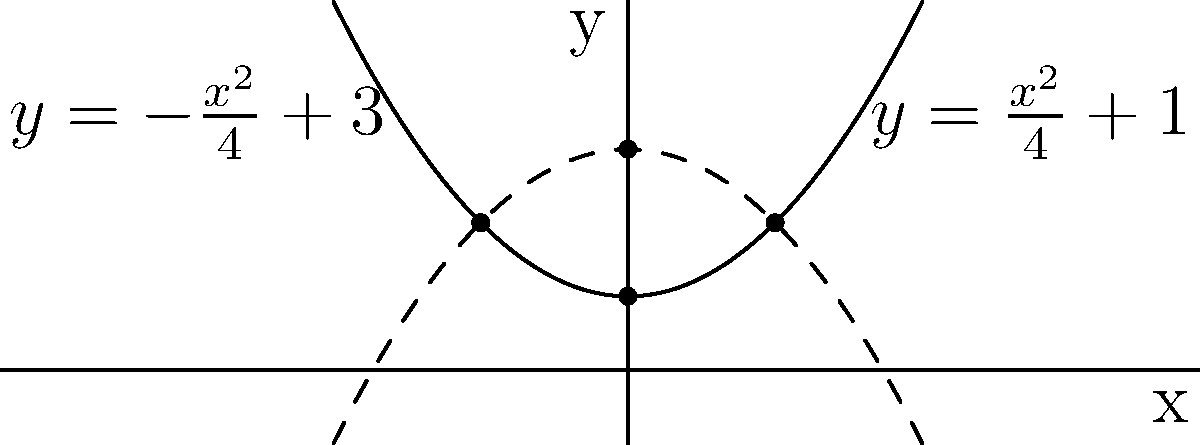In the context of analytic geometry, consider the two parabolas shown in the graph. The solid line represents $y=\frac{x^2}{4}+1$, and the dashed line represents $y=-\frac{x^2}{4}+3$. What is the area of the region enclosed by these two parabolas? To find the area enclosed by the two parabolas, we'll follow these steps:

1) First, we need to find the points of intersection. We can do this by equating the two equations:

   $\frac{x^2}{4}+1 = -\frac{x^2}{4}+3$

2) Simplifying:
   
   $\frac{x^2}{2} = 2$
   $x^2 = 4$
   $x = \pm 2$

3) So the parabolas intersect at $(-2,2)$ and $(2,2)$.

4) The area between the curves can be found by integrating the difference of the functions from $-2$ to $2$:

   $A = \int_{-2}^{2} [(-\frac{x^2}{4}+3) - (\frac{x^2}{4}+1)] dx$

5) Simplifying the integrand:
   
   $A = \int_{-2}^{2} [-\frac{x^2}{2}+2] dx$

6) Integrating:
   
   $A = [-\frac{x^3}{6}+2x]_{-2}^{2}$

7) Evaluating the definite integral:
   
   $A = [-\frac{8}{6}+4] - [-\frac{-8}{6}-4] = \frac{16}{3}$

Therefore, the area enclosed by the two parabolas is $\frac{16}{3}$ square units.
Answer: $\frac{16}{3}$ square units 